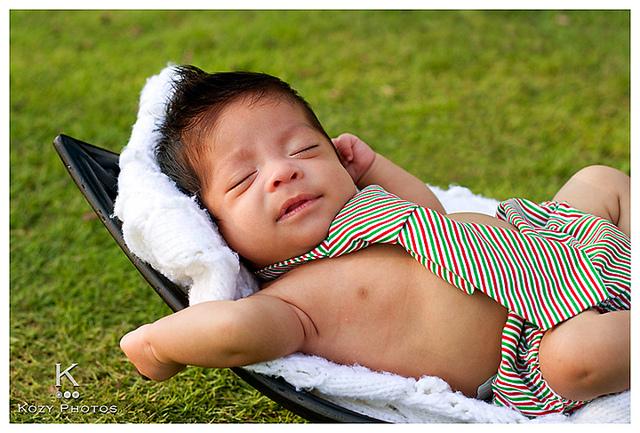Could the baby be asleep?
Keep it brief. Yes. What is the baby laying on?
Concise answer only. Blanket. What two articles are matching?
Be succinct. Tie and diaper. 